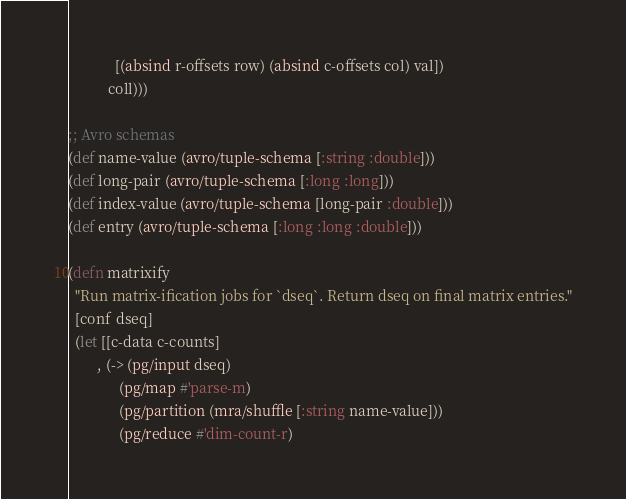<code> <loc_0><loc_0><loc_500><loc_500><_Clojure_>             [(absind r-offsets row) (absind c-offsets col) val])
           coll)))

;; Avro schemas
(def name-value (avro/tuple-schema [:string :double]))
(def long-pair (avro/tuple-schema [:long :long]))
(def index-value (avro/tuple-schema [long-pair :double]))
(def entry (avro/tuple-schema [:long :long :double]))

(defn matrixify
  "Run matrix-ification jobs for `dseq`. Return dseq on final matrix entries."
  [conf dseq]
  (let [[c-data c-counts]
        , (-> (pg/input dseq)
              (pg/map #'parse-m)
              (pg/partition (mra/shuffle [:string name-value]))
              (pg/reduce #'dim-count-r)</code> 